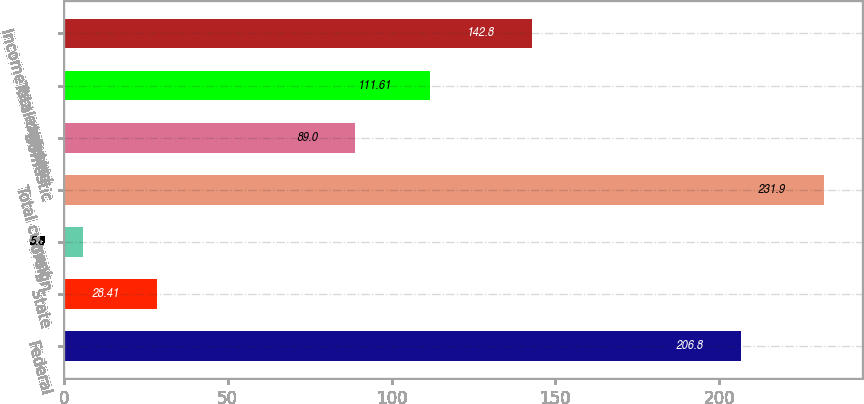Convert chart to OTSL. <chart><loc_0><loc_0><loc_500><loc_500><bar_chart><fcel>Federal<fcel>State<fcel>Foreign<fcel>Total current<fcel>Domestic<fcel>Total deferred<fcel>Income tax expense<nl><fcel>206.8<fcel>28.41<fcel>5.8<fcel>231.9<fcel>89<fcel>111.61<fcel>142.8<nl></chart> 